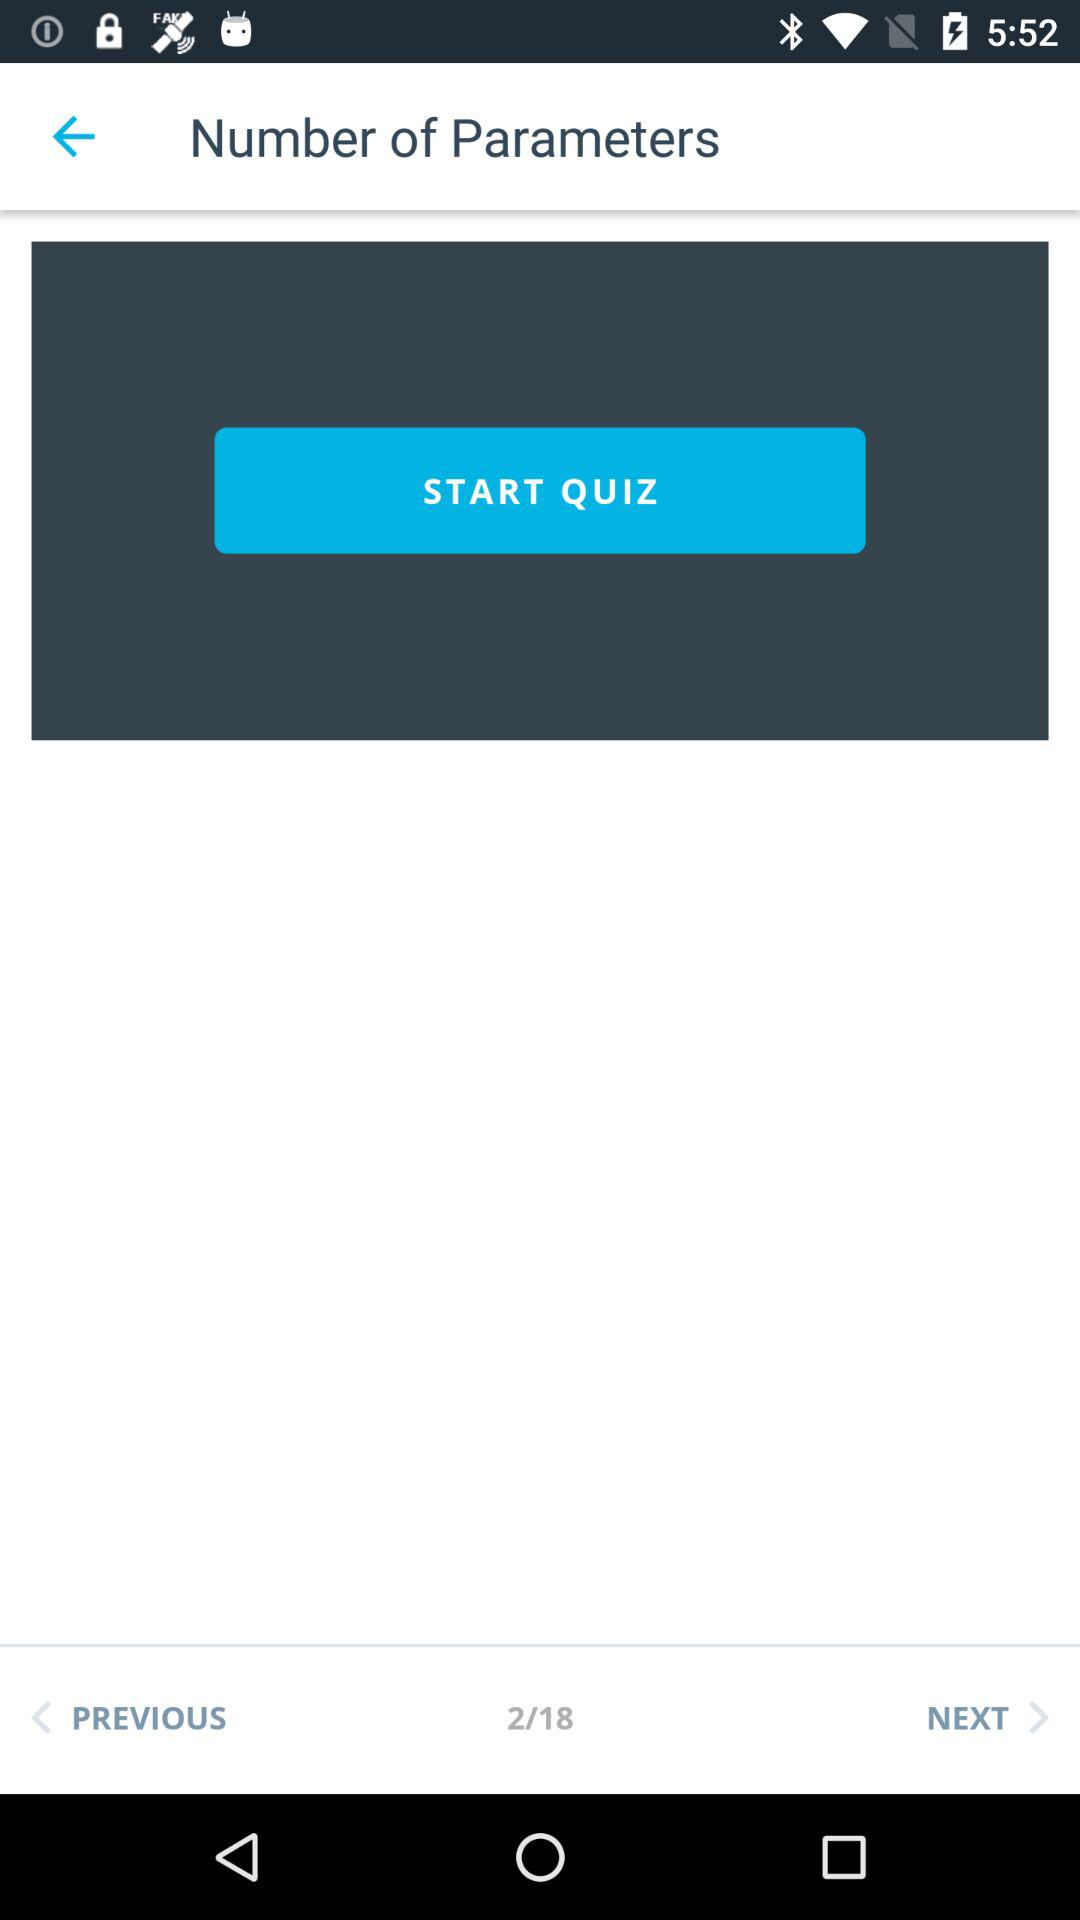How many questions did the user get right on the quiz?
When the provided information is insufficient, respond with <no answer>. <no answer> 